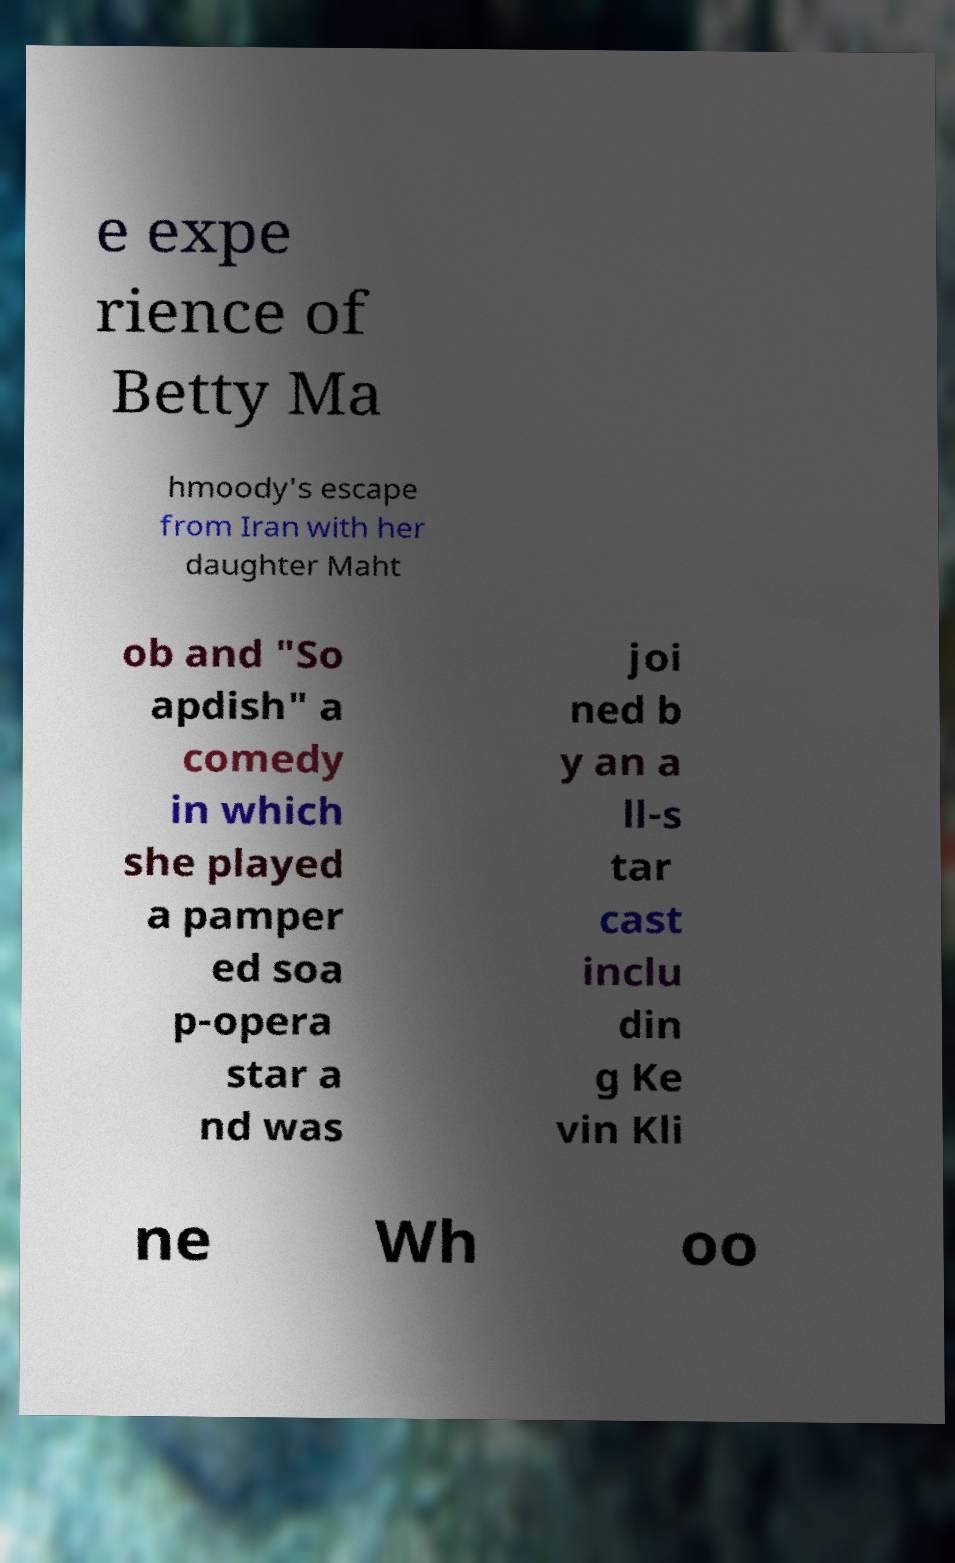Can you accurately transcribe the text from the provided image for me? e expe rience of Betty Ma hmoody's escape from Iran with her daughter Maht ob and "So apdish" a comedy in which she played a pamper ed soa p-opera star a nd was joi ned b y an a ll-s tar cast inclu din g Ke vin Kli ne Wh oo 